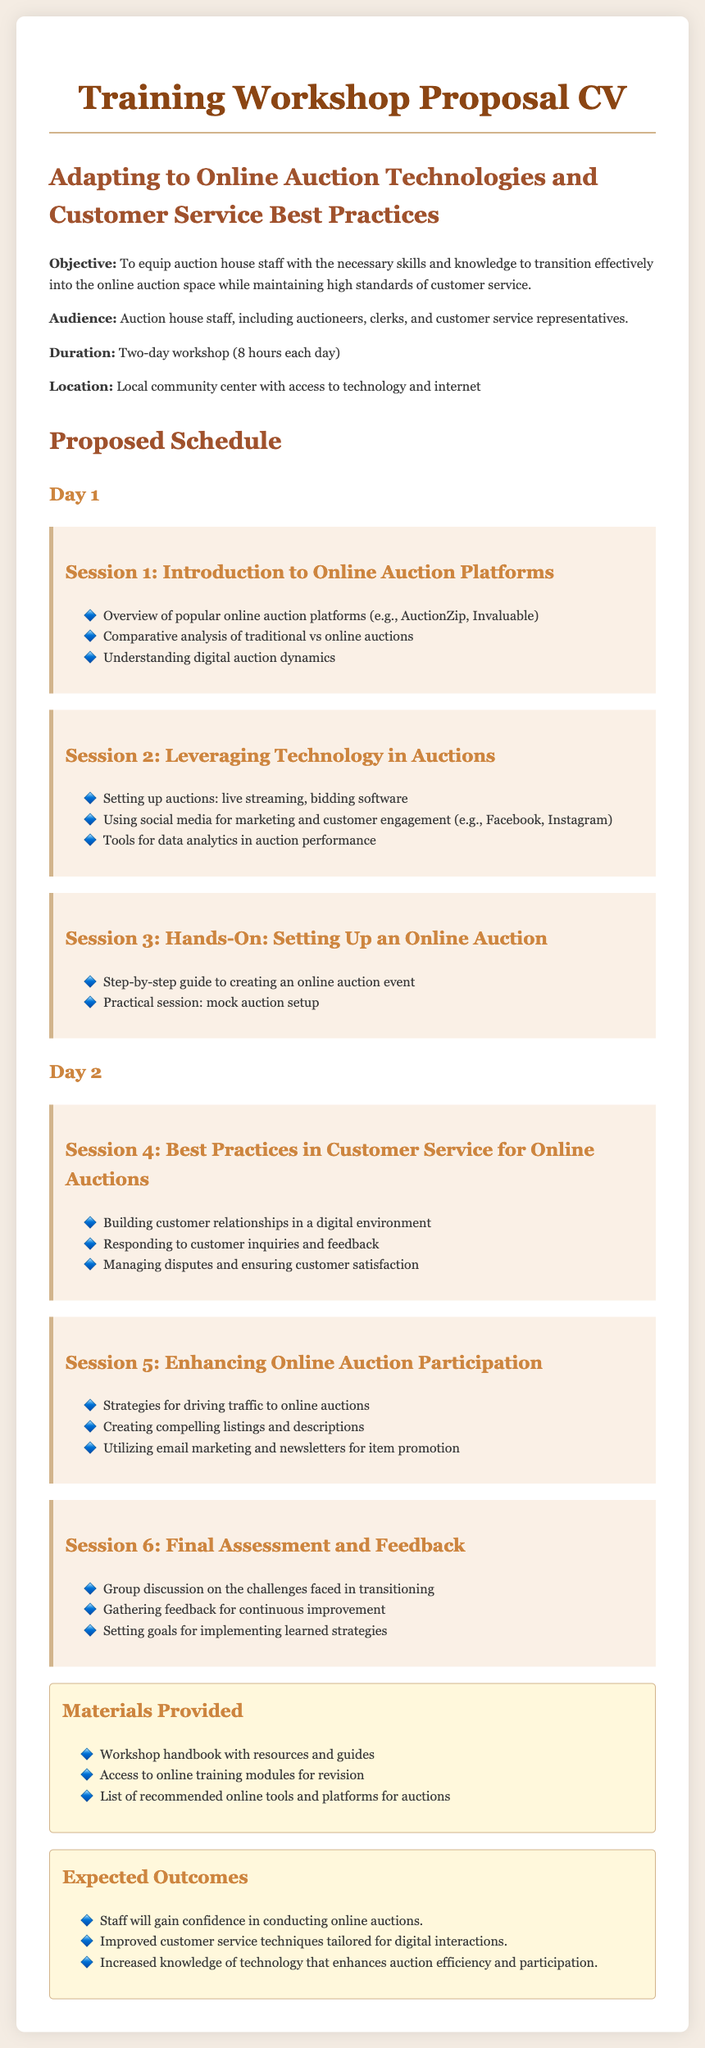What is the objective of the training workshop? The objective is to equip auction house staff with the necessary skills and knowledge to transition effectively into the online auction space while maintaining high standards of customer service.
Answer: To equip auction house staff with the necessary skills and knowledge to transition effectively into the online auction space while maintaining high standards of customer service How long is the workshop scheduled for? The document states the duration of the workshop, which is two days with 8 hours each day.
Answer: Two-day workshop (8 hours each day) What is the location of the training workshop? The location mentioned in the document is the local community center with access to technology and internet.
Answer: Local community center with access to technology and internet What is covered in Session 4? The content of Session 4 is about best practices in customer service for online auctions, including building customer relationships and responding to inquiries.
Answer: Best Practices in Customer Service for Online Auctions How many sessions are there in total? The document lists a total of six sessions planned across two days.
Answer: Six sessions What materials are provided to participants? The document lists three specific materials provided to participants, including a workshop handbook and access to online training modules.
Answer: Workshop handbook with resources and guides What is one expected outcome of the workshop? The expected outcomes section lists several outcomes, one of which is gaining confidence in conducting online auctions.
Answer: Staff will gain confidence in conducting online auctions What is the focus of Session 2? Session 2 focuses on leveraging technology in auctions, covering topics such as setting up auctions and using social media.
Answer: Leveraging Technology in Auctions What does the proposed schedule divide the workshop into? The proposed schedule divides the workshop into two days, each containing three sessions.
Answer: Two days 